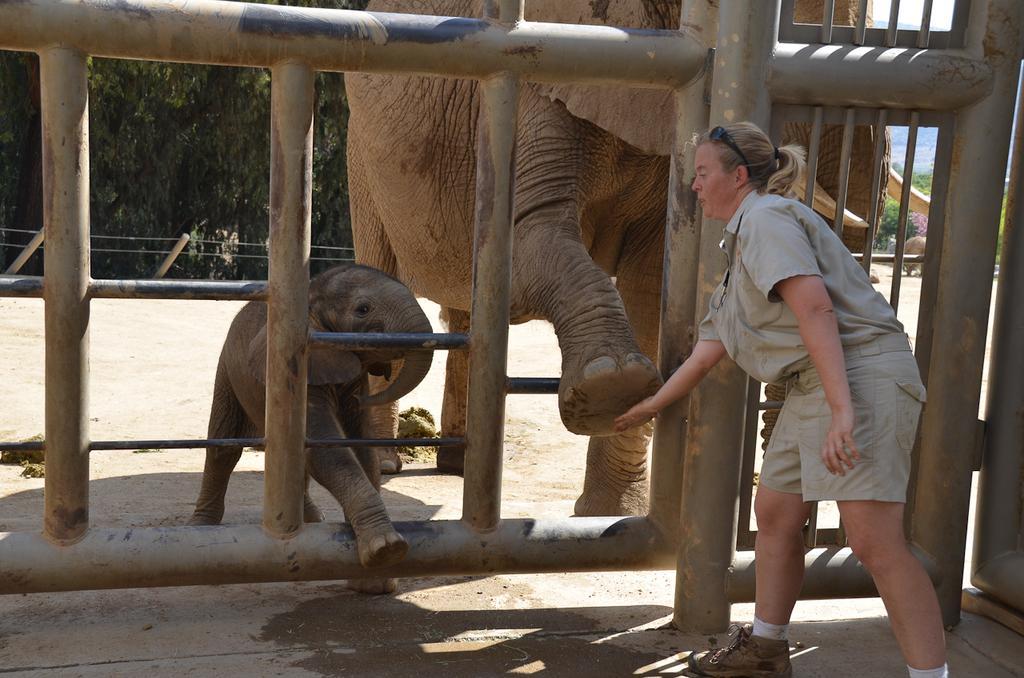Describe this image in one or two sentences. In this image we can see elephants and a woman touching the foot of an elephant. In the background we can see sand, wooden grill, poles, trees and sky. 